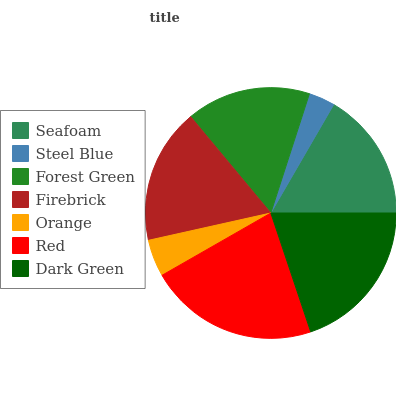Is Steel Blue the minimum?
Answer yes or no. Yes. Is Red the maximum?
Answer yes or no. Yes. Is Forest Green the minimum?
Answer yes or no. No. Is Forest Green the maximum?
Answer yes or no. No. Is Forest Green greater than Steel Blue?
Answer yes or no. Yes. Is Steel Blue less than Forest Green?
Answer yes or no. Yes. Is Steel Blue greater than Forest Green?
Answer yes or no. No. Is Forest Green less than Steel Blue?
Answer yes or no. No. Is Seafoam the high median?
Answer yes or no. Yes. Is Seafoam the low median?
Answer yes or no. Yes. Is Steel Blue the high median?
Answer yes or no. No. Is Firebrick the low median?
Answer yes or no. No. 